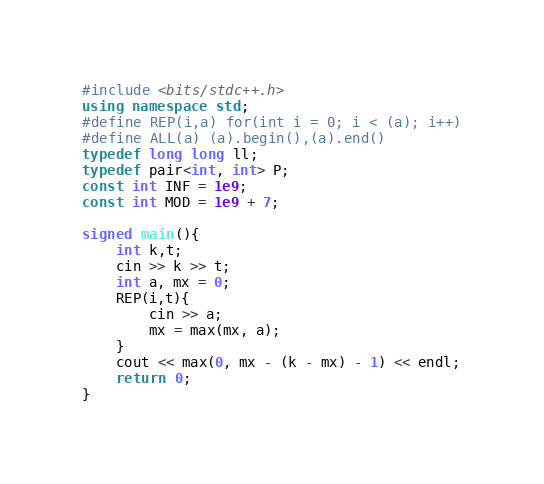Convert code to text. <code><loc_0><loc_0><loc_500><loc_500><_C++_>#include <bits/stdc++.h>
using namespace std;
#define REP(i,a) for(int i = 0; i < (a); i++)
#define ALL(a) (a).begin(),(a).end()
typedef long long ll;
typedef pair<int, int> P;
const int INF = 1e9;
const int MOD = 1e9 + 7;

signed main(){
    int k,t;
    cin >> k >> t;
    int a, mx = 0;
    REP(i,t){
        cin >> a;
        mx = max(mx, a);
    }
    cout << max(0, mx - (k - mx) - 1) << endl;
    return 0;
}</code> 